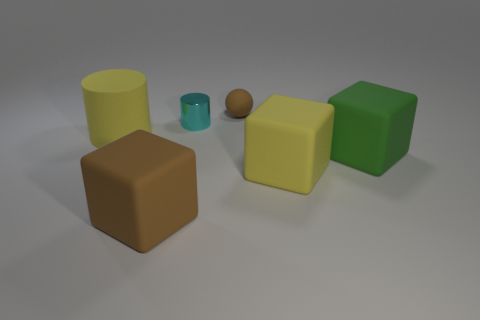Does the large rubber object that is behind the big green block have the same color as the cylinder that is to the right of the yellow cylinder?
Make the answer very short. No. There is a brown rubber object behind the yellow thing right of the big yellow rubber cylinder that is to the left of the small sphere; what is its shape?
Your answer should be very brief. Sphere. The rubber thing that is both behind the green rubber cube and left of the rubber sphere has what shape?
Offer a terse response. Cylinder. There is a matte thing that is in front of the yellow matte object right of the sphere; how many green matte things are in front of it?
Provide a short and direct response. 0. What is the size of the brown object that is the same shape as the green thing?
Your answer should be very brief. Large. Are there any other things that are the same size as the green matte cube?
Offer a terse response. Yes. Is the large cube that is to the left of the cyan shiny cylinder made of the same material as the yellow block?
Ensure brevity in your answer.  Yes. What color is the rubber thing that is the same shape as the small shiny object?
Offer a very short reply. Yellow. How many other objects are there of the same color as the small ball?
Give a very brief answer. 1. Do the large yellow matte thing left of the tiny metal cylinder and the matte object behind the small cyan cylinder have the same shape?
Offer a terse response. No. 